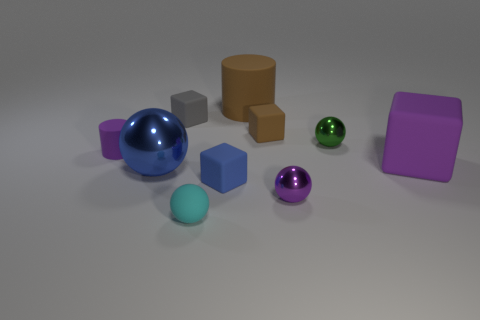How many other things are there of the same material as the large blue sphere?
Your answer should be compact. 2. Is the tiny brown object made of the same material as the small purple object on the left side of the purple ball?
Provide a succinct answer. Yes. How many things are either matte things that are to the left of the blue block or shiny objects right of the brown matte cylinder?
Offer a very short reply. 5. How many other objects are there of the same color as the large cylinder?
Provide a short and direct response. 1. Is the number of tiny metallic objects that are to the left of the large blue thing greater than the number of brown objects right of the purple metal object?
Keep it short and to the point. No. Is there any other thing that has the same size as the green object?
Ensure brevity in your answer.  Yes. How many blocks are blue rubber things or brown objects?
Offer a very short reply. 2. What number of objects are cubes left of the brown matte cylinder or small brown matte blocks?
Give a very brief answer. 3. What shape is the brown object that is in front of the large matte object behind the cylinder to the left of the tiny gray object?
Give a very brief answer. Cube. How many large purple things have the same shape as the green object?
Provide a succinct answer. 0. 